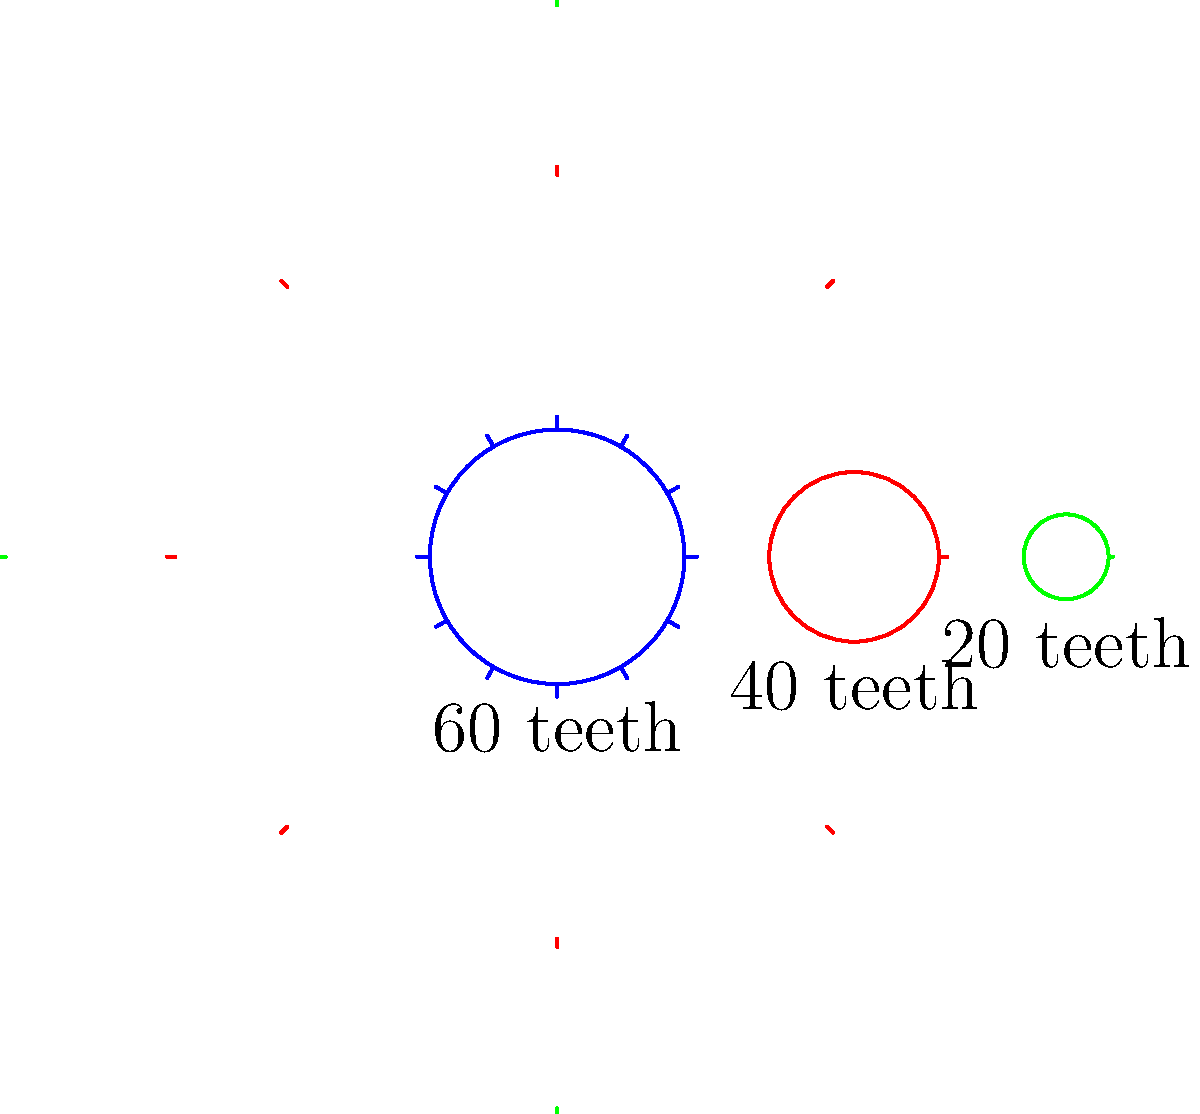In a hypothetical crafting system for a new strategy game, you're designing a gear mechanism for a rare item. The system consists of three gears as shown in the diagram. The first gear has 60 teeth, the second has 40 teeth, and the third has 20 teeth. If the first gear makes 10 complete rotations, how many rotations will the third gear make? To solve this problem, we need to follow these steps:

1. Calculate the gear ratio between the first and second gears:
   $$\text{Ratio}_{\text{1,2}} = \frac{\text{Teeth}_{\text{1}}}{\text{Teeth}_{\text{2}}} = \frac{60}{40} = 1.5$$

2. Calculate the gear ratio between the second and third gears:
   $$\text{Ratio}_{\text{2,3}} = \frac{\text{Teeth}_{\text{2}}}{\text{Teeth}_{\text{3}}} = \frac{40}{20} = 2$$

3. Calculate the overall gear ratio from the first to the third gear:
   $$\text{Ratio}_{\text{1,3}} = \text{Ratio}_{\text{1,2}} \times \text{Ratio}_{\text{2,3}} = 1.5 \times 2 = 3$$

4. Determine the number of rotations of the third gear:
   $$\text{Rotations}_{\text{3}} = \text{Rotations}_{\text{1}} \times \text{Ratio}_{\text{1,3}} = 10 \times 3 = 30$$

Therefore, when the first gear makes 10 complete rotations, the third gear will make 30 complete rotations.
Answer: 30 rotations 